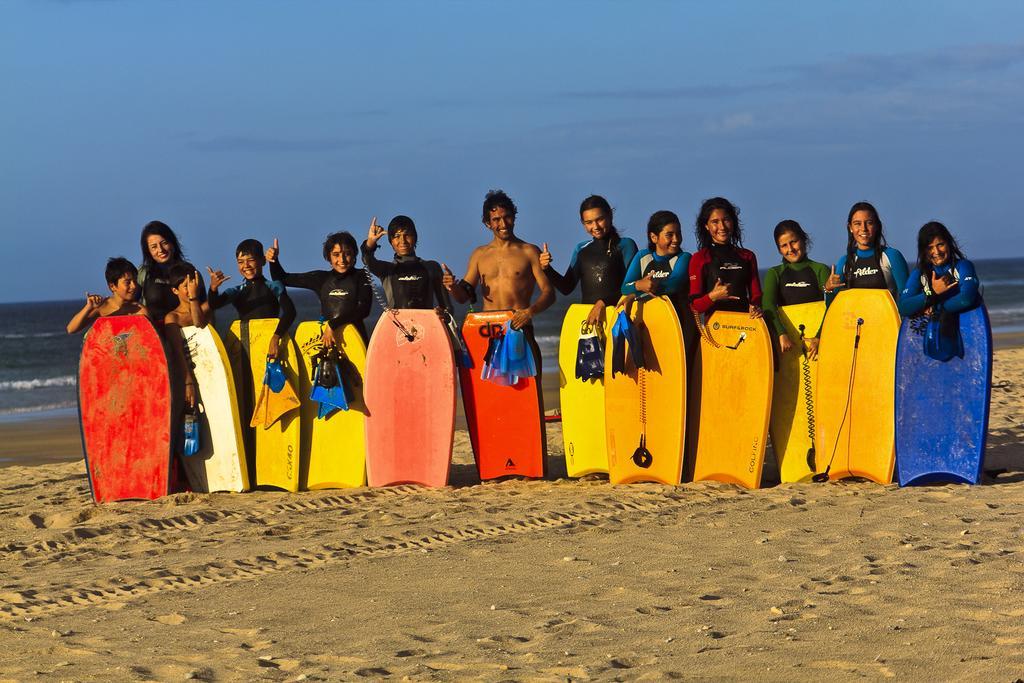Could you give a brief overview of what you see in this image? It is an outdoor picture where people are standing at the beach holding their boards with them shoes with them. Behind them there is a sea and the sky is very clear and in the center of the picture one person is standing without a shirt. 